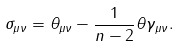<formula> <loc_0><loc_0><loc_500><loc_500>\sigma _ { \mu \nu } = \theta _ { \mu \nu } - \frac { 1 } { n - 2 } \theta \gamma _ { \mu \nu } .</formula> 